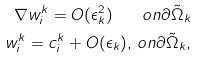Convert formula to latex. <formula><loc_0><loc_0><loc_500><loc_500>\nabla w _ { i } ^ { k } = O ( \epsilon _ { k } ^ { 2 } ) \quad o n \partial \tilde { \Omega } _ { k } \\ w _ { i } ^ { k } = c _ { i } ^ { k } + O ( \epsilon _ { k } ) , \, o n \partial \tilde { \Omega } _ { k } ,</formula> 